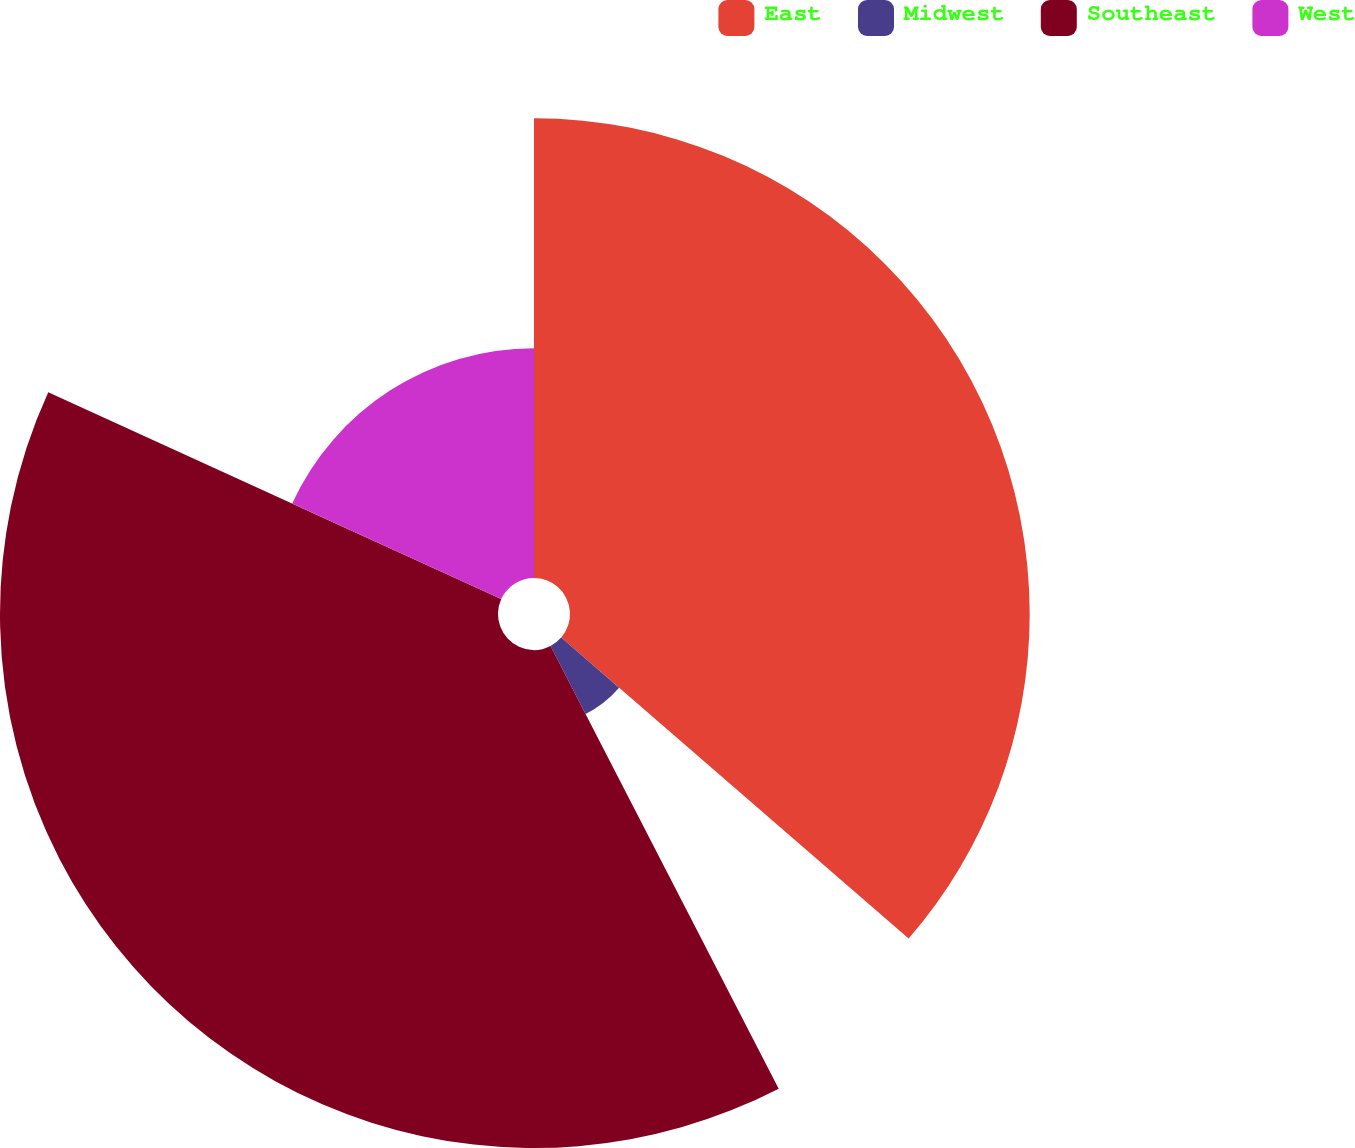Convert chart to OTSL. <chart><loc_0><loc_0><loc_500><loc_500><pie_chart><fcel>East<fcel>Midwest<fcel>Southeast<fcel>West<nl><fcel>36.36%<fcel>6.06%<fcel>39.39%<fcel>18.18%<nl></chart> 